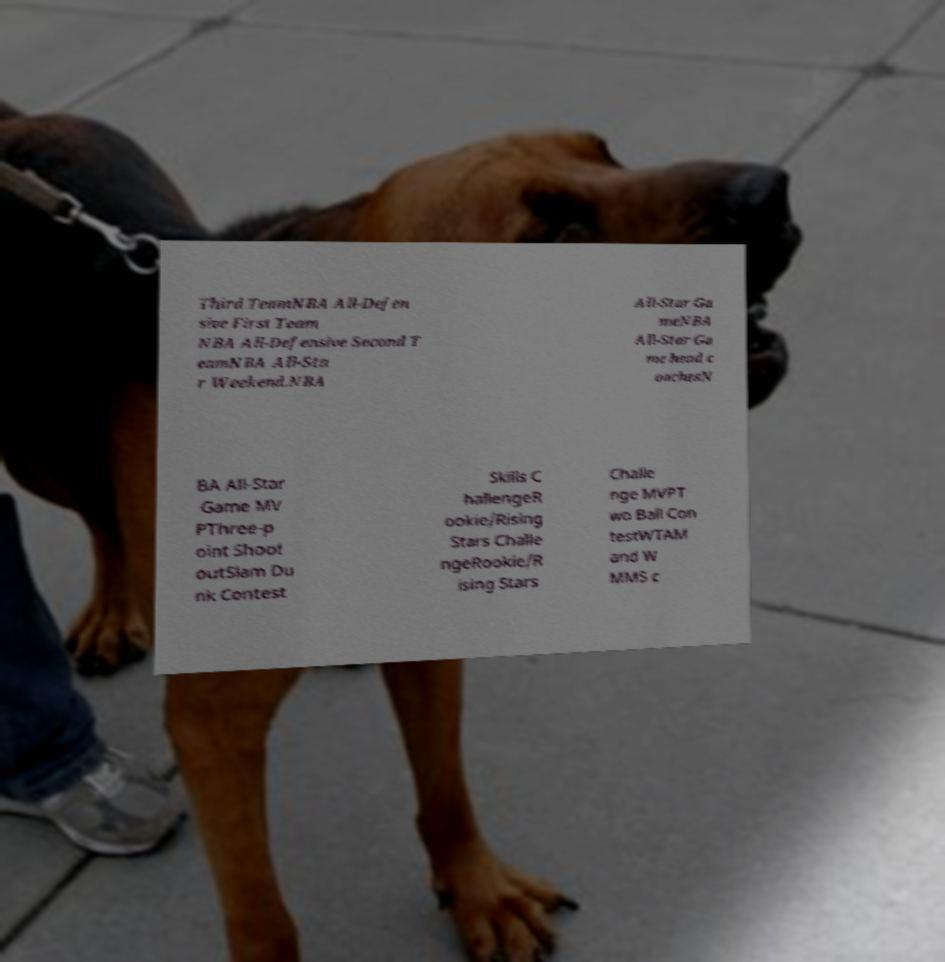Can you accurately transcribe the text from the provided image for me? Third TeamNBA All-Defen sive First Team NBA All-Defensive Second T eamNBA All-Sta r Weekend.NBA All-Star Ga meNBA All-Star Ga me head c oachesN BA All-Star Game MV PThree-p oint Shoot outSlam Du nk Contest Skills C hallengeR ookie/Rising Stars Challe ngeRookie/R ising Stars Challe nge MVPT wo Ball Con testWTAM and W MMS c 